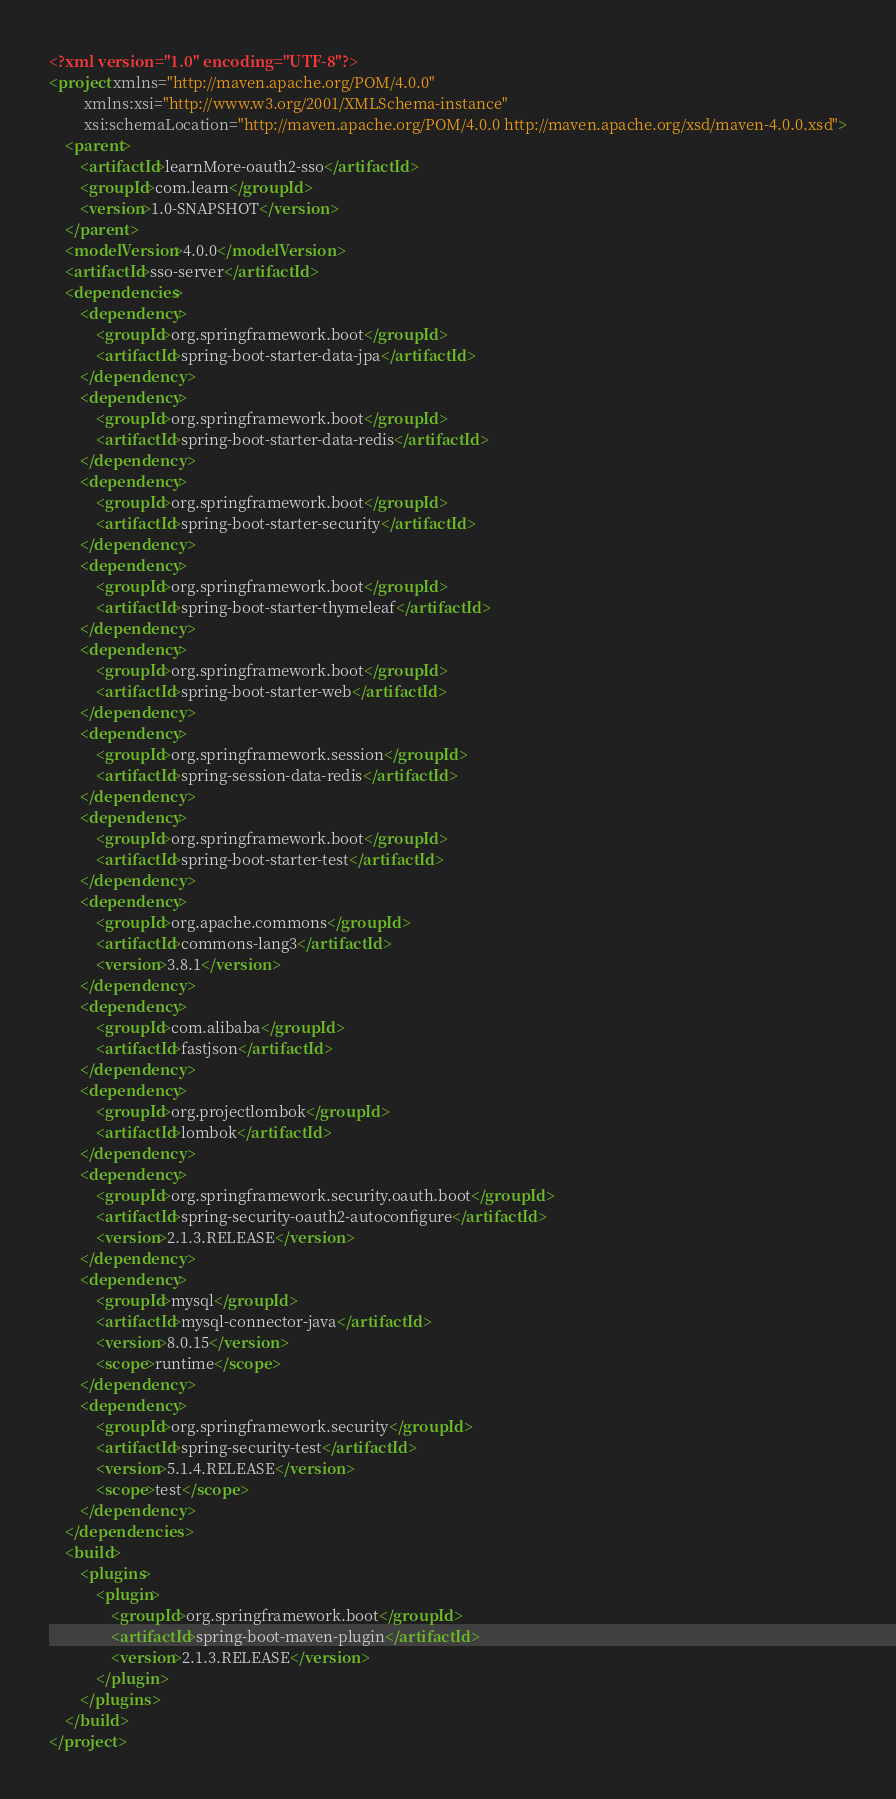<code> <loc_0><loc_0><loc_500><loc_500><_XML_><?xml version="1.0" encoding="UTF-8"?>
<project xmlns="http://maven.apache.org/POM/4.0.0"
         xmlns:xsi="http://www.w3.org/2001/XMLSchema-instance"
         xsi:schemaLocation="http://maven.apache.org/POM/4.0.0 http://maven.apache.org/xsd/maven-4.0.0.xsd">
    <parent>
        <artifactId>learnMore-oauth2-sso</artifactId>
        <groupId>com.learn</groupId>
        <version>1.0-SNAPSHOT</version>
    </parent>
    <modelVersion>4.0.0</modelVersion>
    <artifactId>sso-server</artifactId>
    <dependencies>
        <dependency>
            <groupId>org.springframework.boot</groupId>
            <artifactId>spring-boot-starter-data-jpa</artifactId>
        </dependency>
        <dependency>
            <groupId>org.springframework.boot</groupId>
            <artifactId>spring-boot-starter-data-redis</artifactId>
        </dependency>
        <dependency>
            <groupId>org.springframework.boot</groupId>
            <artifactId>spring-boot-starter-security</artifactId>
        </dependency>
        <dependency>
            <groupId>org.springframework.boot</groupId>
            <artifactId>spring-boot-starter-thymeleaf</artifactId>
        </dependency>
        <dependency>
            <groupId>org.springframework.boot</groupId>
            <artifactId>spring-boot-starter-web</artifactId>
        </dependency>
        <dependency>
            <groupId>org.springframework.session</groupId>
            <artifactId>spring-session-data-redis</artifactId>
        </dependency>
        <dependency>
            <groupId>org.springframework.boot</groupId>
            <artifactId>spring-boot-starter-test</artifactId>
        </dependency>
        <dependency>
            <groupId>org.apache.commons</groupId>
            <artifactId>commons-lang3</artifactId>
            <version>3.8.1</version>
        </dependency>
        <dependency>
            <groupId>com.alibaba</groupId>
            <artifactId>fastjson</artifactId>
        </dependency>
        <dependency>
            <groupId>org.projectlombok</groupId>
            <artifactId>lombok</artifactId>
        </dependency>
        <dependency>
            <groupId>org.springframework.security.oauth.boot</groupId>
            <artifactId>spring-security-oauth2-autoconfigure</artifactId>
            <version>2.1.3.RELEASE</version>
        </dependency>
        <dependency>
            <groupId>mysql</groupId>
            <artifactId>mysql-connector-java</artifactId>
            <version>8.0.15</version>
            <scope>runtime</scope>
        </dependency>
        <dependency>
            <groupId>org.springframework.security</groupId>
            <artifactId>spring-security-test</artifactId>
            <version>5.1.4.RELEASE</version>
            <scope>test</scope>
        </dependency>
    </dependencies>
    <build>
        <plugins>
            <plugin>
                <groupId>org.springframework.boot</groupId>
                <artifactId>spring-boot-maven-plugin</artifactId>
                <version>2.1.3.RELEASE</version>
            </plugin>
        </plugins>
    </build>
</project></code> 